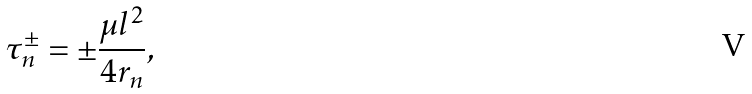Convert formula to latex. <formula><loc_0><loc_0><loc_500><loc_500>\tau _ { n } ^ { \pm } = \pm \frac { \mu l ^ { 2 } } { 4 r _ { n } } ,</formula> 